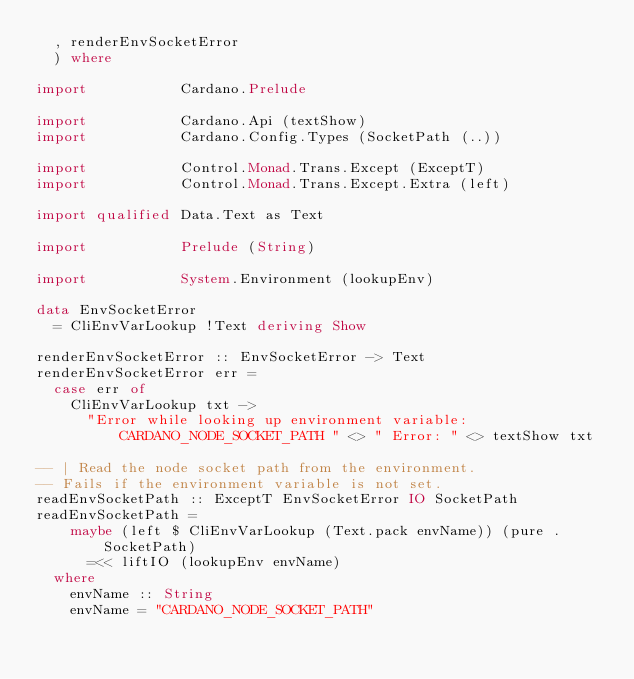Convert code to text. <code><loc_0><loc_0><loc_500><loc_500><_Haskell_>  , renderEnvSocketError
  ) where

import           Cardano.Prelude

import           Cardano.Api (textShow)
import           Cardano.Config.Types (SocketPath (..))

import           Control.Monad.Trans.Except (ExceptT)
import           Control.Monad.Trans.Except.Extra (left)

import qualified Data.Text as Text

import           Prelude (String)

import           System.Environment (lookupEnv)

data EnvSocketError
  = CliEnvVarLookup !Text deriving Show

renderEnvSocketError :: EnvSocketError -> Text
renderEnvSocketError err =
  case err of
    CliEnvVarLookup txt ->
      "Error while looking up environment variable: CARDANO_NODE_SOCKET_PATH " <> " Error: " <> textShow txt

-- | Read the node socket path from the environment.
-- Fails if the environment variable is not set.
readEnvSocketPath :: ExceptT EnvSocketError IO SocketPath
readEnvSocketPath =
    maybe (left $ CliEnvVarLookup (Text.pack envName)) (pure . SocketPath)
      =<< liftIO (lookupEnv envName)
  where
    envName :: String
    envName = "CARDANO_NODE_SOCKET_PATH"
</code> 